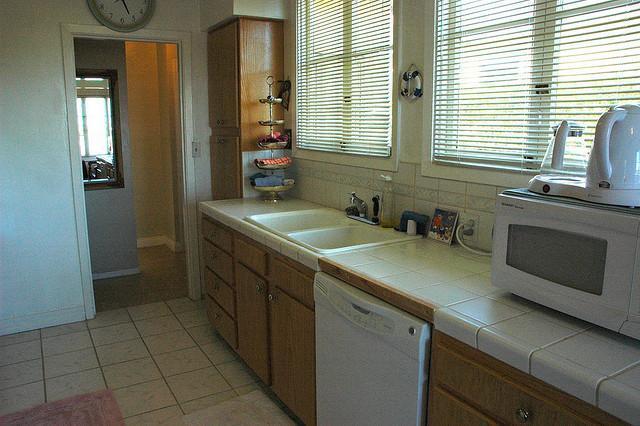How many sinks are there?
Give a very brief answer. 2. 